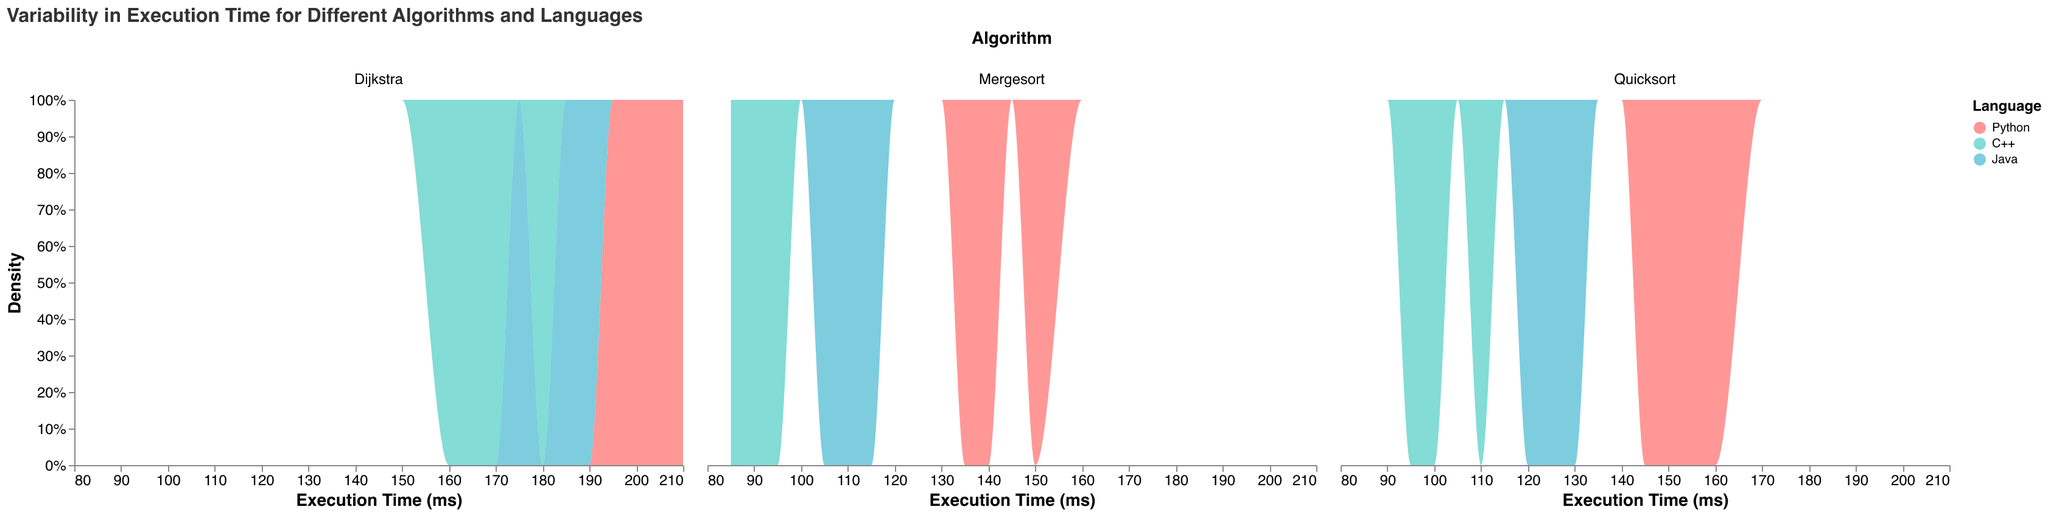What is the title of the plot? The title of the plot is typically placed at the top and summarizes the main topic of the plot. In this case, it reads "Variability in Execution Time for Different Algorithms and Languages".
Answer: Variability in Execution Time for Different Algorithms and Languages What does the x-axis represent? The x-axis represents the quantitative measure being analyzed in the plot. Here, it represents the "Execution Time (ms)".
Answer: Execution Time (ms) Which programming language has the highest peak density for the Quicksort algorithm? To find the highest peak density for Quicksort, one can compare the y-axis values of the different color-coded areas in the Quicksort column. The color corresponding to C++ reaches the highest point, indicating the highest density.
Answer: C++ What color represents Java in the plot? The color representing each programming language can be found in the legend to the right. Java is represented by a light blue color.
Answer: Light Blue For the Dijkstra algorithm, which programming language shows the most variability in execution time? Variability can be assessed by the spread of the densities along the x-axis. For Dijkstra, the density areas are widest for Python, spanning execution times from about 195 to 210 ms.
Answer: Python Compare the execution times of Mergesort in Python and C++. Which language appears faster on average? For a rough comparison, we look at the peak densities for each language. The peak density for Python is around 140-150 ms, whereas for C++, it is around 85-95 ms. C++ appears faster on average.
Answer: C++ For which algorithm does Java have the lowest execution time variability? To find the lowest execution time variability, we observe the spread of the densities for Java across different algorithms. For Mergesort, the density is tightly packed around 105-115 ms, indicating low variability.
Answer: Mergesort How does the execution time of Dijkstra in C++ compare to Dijkstra in Java? To compare the execution times, observe the overlap and peak density regions. Dijkstra in C++ shows peak density around 160-180 ms, whereas Java peaks around 175-190 ms. C++ is faster on average.
Answer: C++ is faster What does the y-axis represent? The y-axis represents the density of execution times, normalized to compare distributions directly. The higher the value, the more frequently that execution time occurs.
Answer: Density 